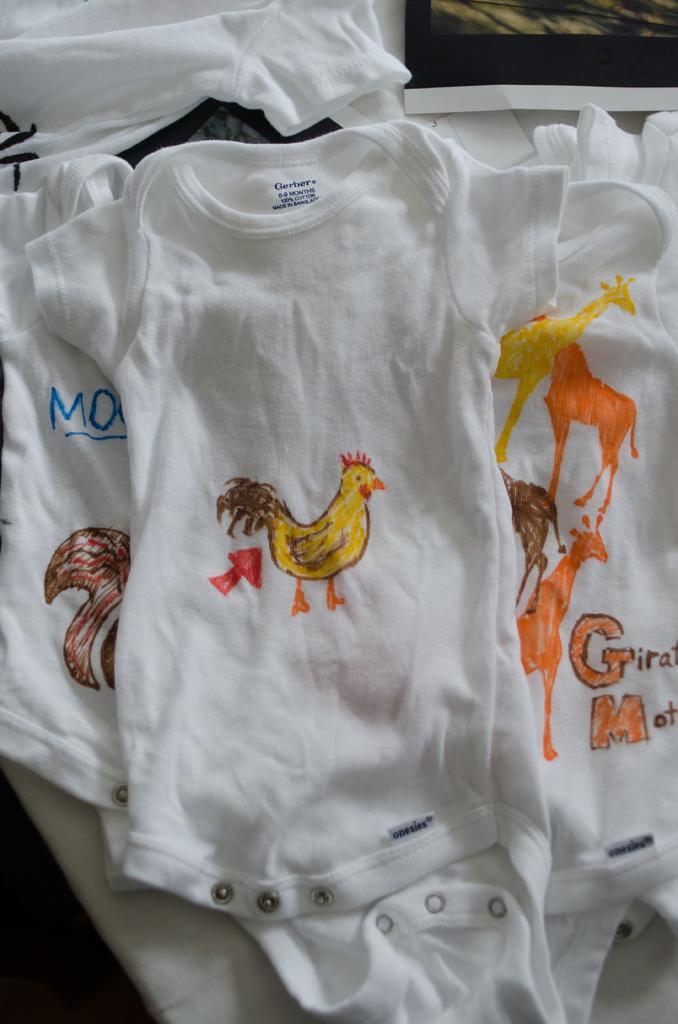Describe this image in one or two sentences. In this image in the center there are some t shirts and on the t shirts, and in the background there are some objects. 